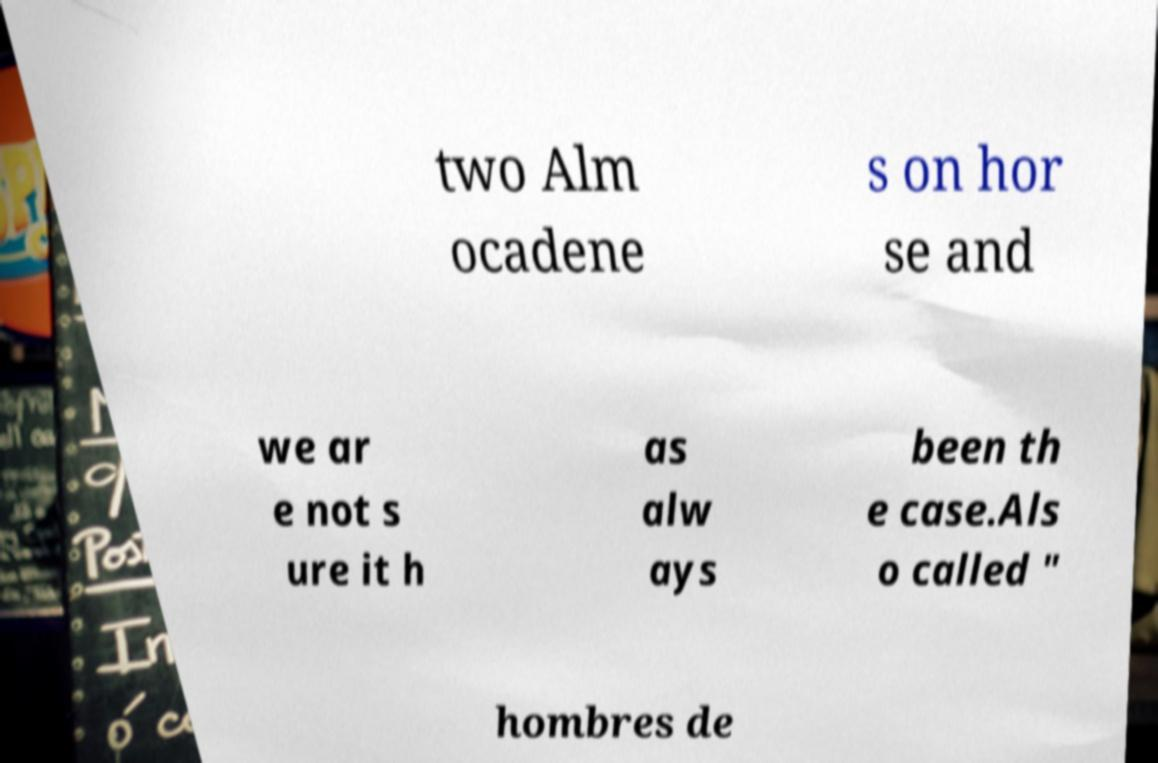I need the written content from this picture converted into text. Can you do that? two Alm ocadene s on hor se and we ar e not s ure it h as alw ays been th e case.Als o called " hombres de 